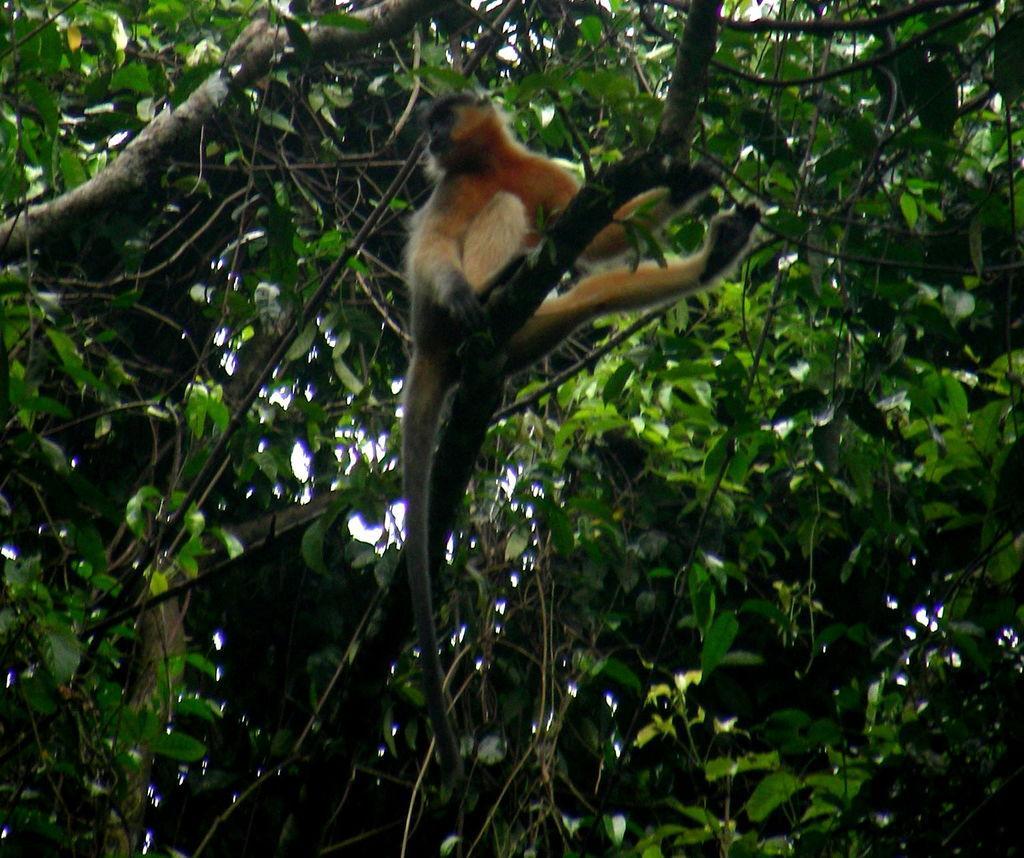Can you describe this image briefly? In this image we can see a monkey on a branch of a tree. In the background we can see branches with leaves. 